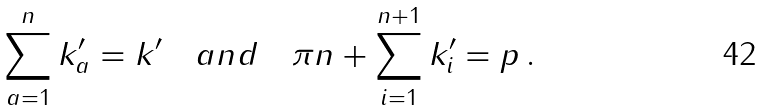Convert formula to latex. <formula><loc_0><loc_0><loc_500><loc_500>\sum _ { a = 1 } ^ { n } k ^ { \prime } _ { a } = k ^ { \prime } \quad a n d \quad \pi n + \sum _ { i = 1 } ^ { n + 1 } k ^ { \prime } _ { i } = p \, .</formula> 